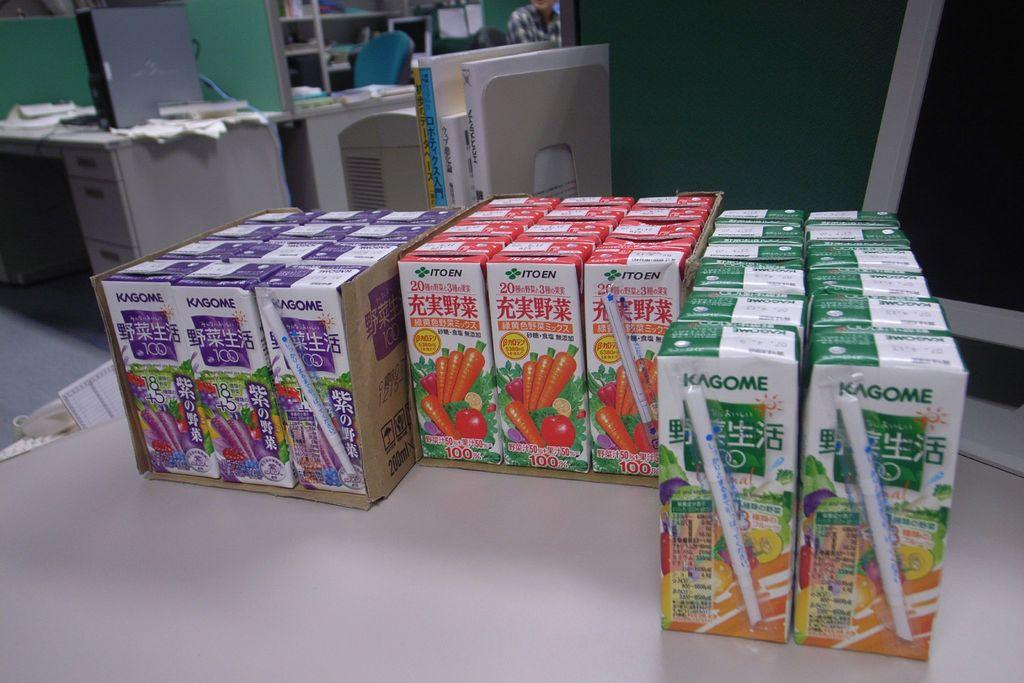<image>
Share a concise interpretation of the image provided. Several juiceboxes lined up with some from the brand Kagome. 